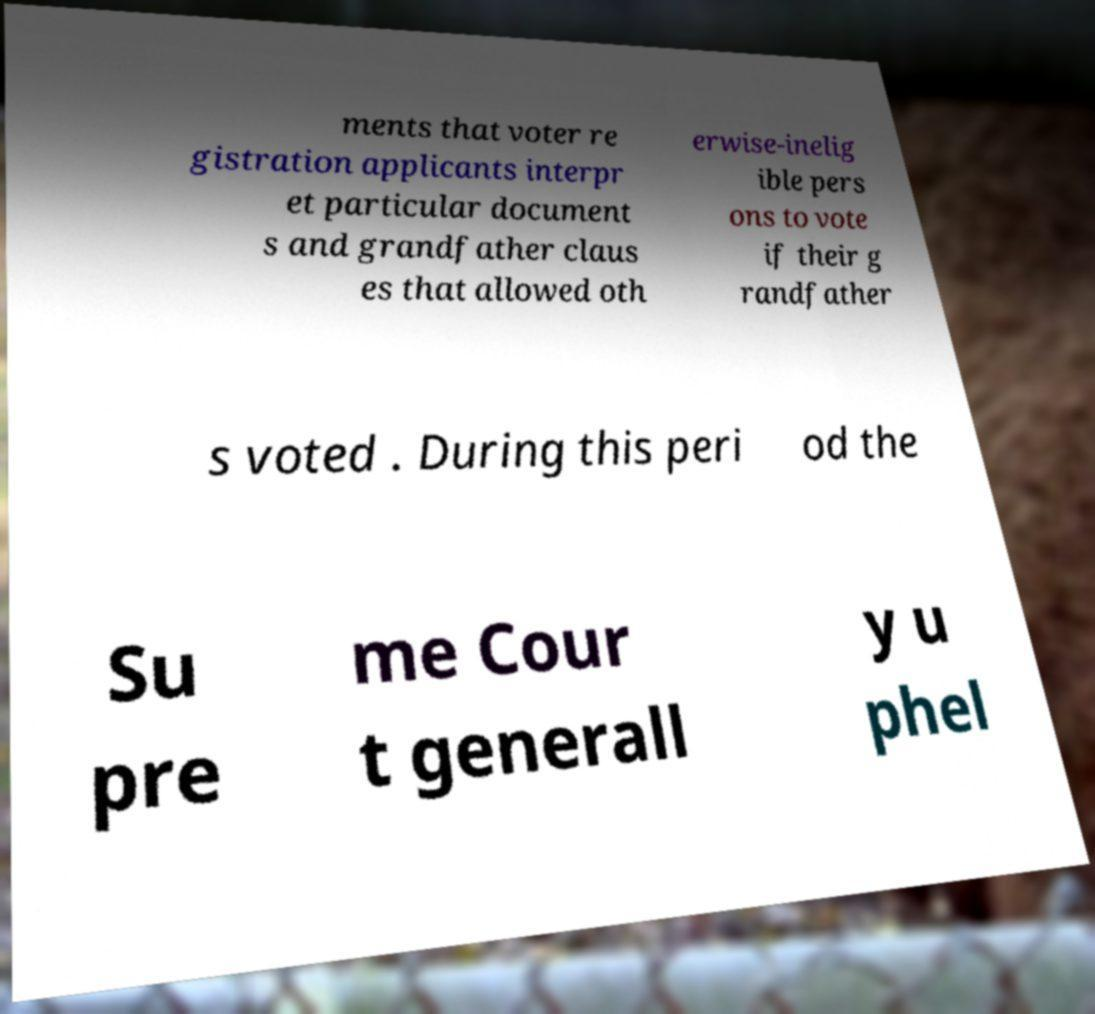Can you read and provide the text displayed in the image?This photo seems to have some interesting text. Can you extract and type it out for me? ments that voter re gistration applicants interpr et particular document s and grandfather claus es that allowed oth erwise-inelig ible pers ons to vote if their g randfather s voted . During this peri od the Su pre me Cour t generall y u phel 